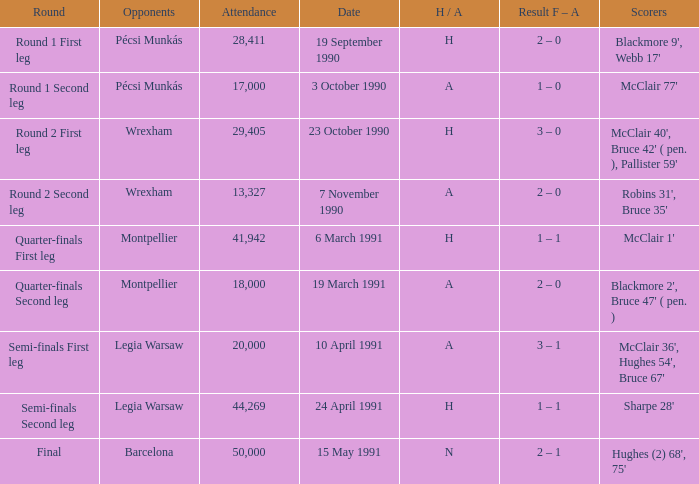What is the attendance number in the final round? 50000.0. 